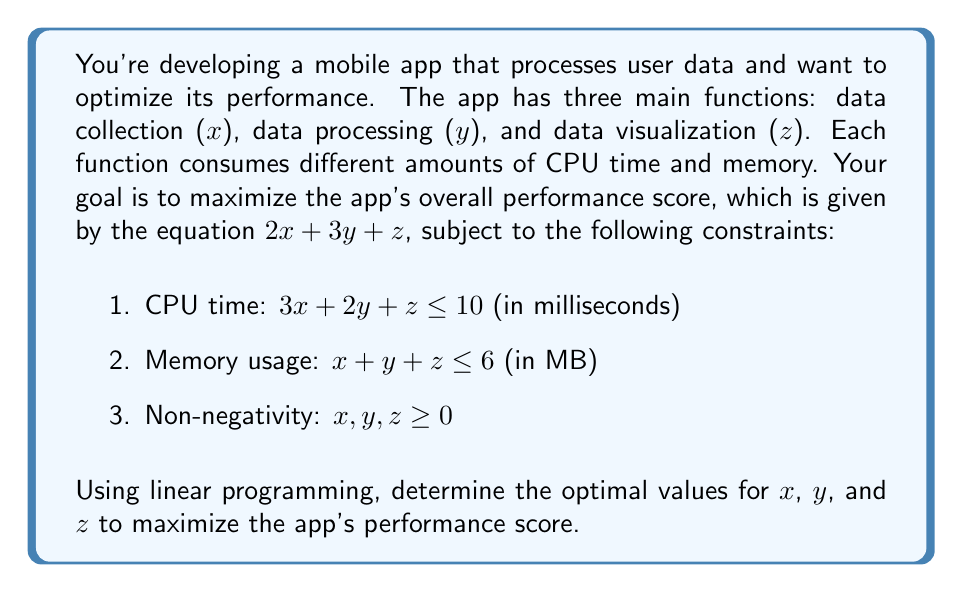Teach me how to tackle this problem. To solve this linear programming problem, we'll use the simplex method:

1. Convert the problem to standard form:
   Maximize: $Z = 2x + 3y + z$
   Subject to:
   $3x + 2y + z + s_1 = 10$
   $x + y + z + s_2 = 6$
   $x, y, z, s_1, s_2 \geq 0$

2. Set up the initial simplex tableau:

   $$
   \begin{array}{c|ccccc|c}
   & x & y & z & s_1 & s_2 & RHS \\
   \hline
   s_1 & 3 & 2 & 1 & 1 & 0 & 10 \\
   s_2 & 1 & 1 & 1 & 0 & 1 & 6 \\
   \hline
   Z & -2 & -3 & -1 & 0 & 0 & 0
   \end{array}
   $$

3. Identify the pivot column (most negative Z-row value): $y$ column

4. Calculate the ratios and identify the pivot row:
   $s_1$ row: $10 / 2 = 5$
   $s_2$ row: $6 / 1 = 6$
   Pivot row: $s_1$ (smallest ratio)

5. Perform row operations to get the new tableau:

   $$
   \begin{array}{c|ccccc|c}
   & x & y & z & s_1 & s_2 & RHS \\
   \hline
   y & 3/2 & 1 & 1/2 & 1/2 & 0 & 5 \\
   s_2 & -1/2 & 0 & 1/2 & -1/2 & 1 & 1 \\
   \hline
   Z & 5/2 & 0 & 1/2 & 3/2 & 0 & 15
   \end{array}
   $$

6. Repeat steps 3-5 until no negative values remain in the Z-row:

   Final tableau:
   $$
   \begin{array}{c|ccccc|c}
   & x & y & z & s_1 & s_2 & RHS \\
   \hline
   y & 0 & 1 & 0 & 1 & -1 & 4 \\
   x & 1 & 0 & 0 & 0 & 1 & 2 \\
   z & 0 & 0 & 1 & 0 & -1 & 0 \\
   \hline
   Z & 0 & 0 & 0 & 1 & 1 & 16
   \end{array}
   $$

7. Read the optimal solution:
   $x = 2, y = 4, z = 0$
   Maximum performance score: $Z = 16$
Answer: $x = 2, y = 4, z = 0$; Max score = 16 